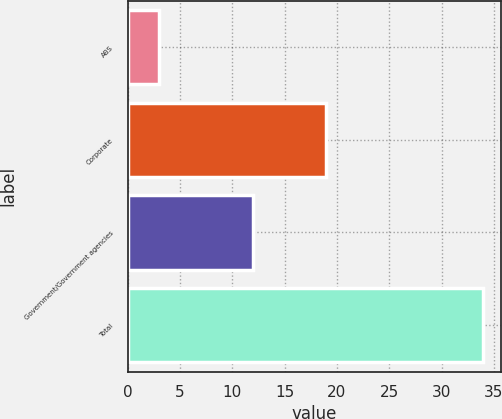<chart> <loc_0><loc_0><loc_500><loc_500><bar_chart><fcel>ABS<fcel>Corporate<fcel>Government/Government agencies<fcel>Total<nl><fcel>3<fcel>19<fcel>12<fcel>34<nl></chart> 